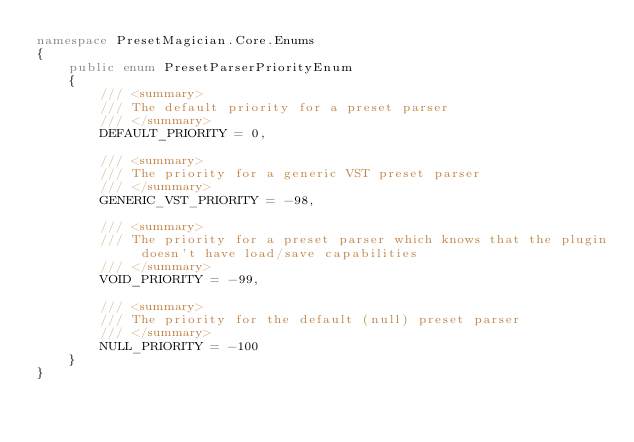Convert code to text. <code><loc_0><loc_0><loc_500><loc_500><_C#_>namespace PresetMagician.Core.Enums
{
    public enum PresetParserPriorityEnum
    {
        /// <summary>
        /// The default priority for a preset parser
        /// </summary>
        DEFAULT_PRIORITY = 0,
        
        /// <summary>
        /// The priority for a generic VST preset parser
        /// </summary>
        GENERIC_VST_PRIORITY = -98,
        
        /// <summary>
        /// The priority for a preset parser which knows that the plugin doesn't have load/save capabilities
        /// </summary>
        VOID_PRIORITY = -99,
        
        /// <summary>
        /// The priority for the default (null) preset parser 
        /// </summary>
        NULL_PRIORITY = -100
    }
}</code> 